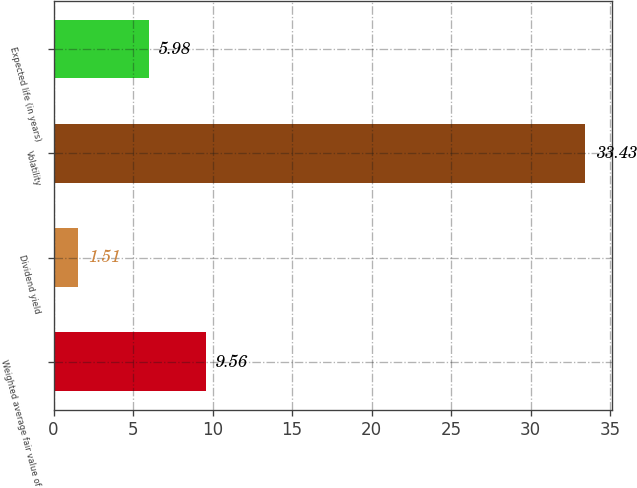Convert chart to OTSL. <chart><loc_0><loc_0><loc_500><loc_500><bar_chart><fcel>Weighted average fair value of<fcel>Dividend yield<fcel>Volatility<fcel>Expected life (in years)<nl><fcel>9.56<fcel>1.51<fcel>33.43<fcel>5.98<nl></chart> 